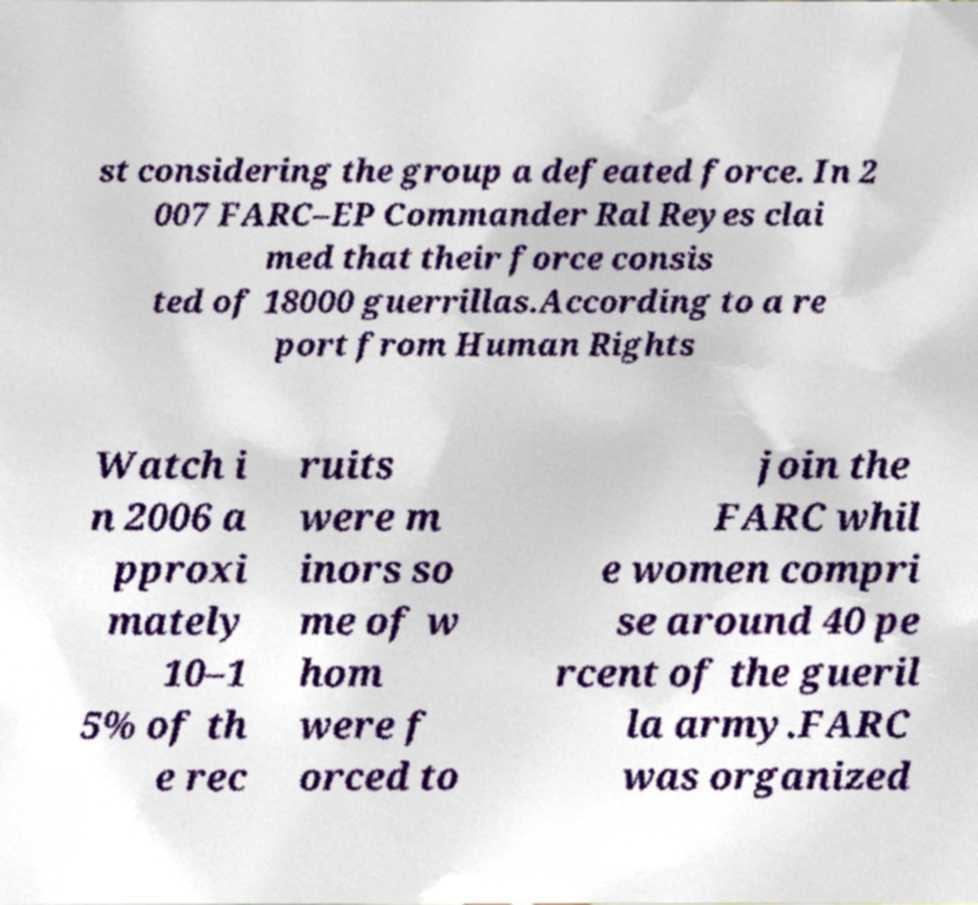I need the written content from this picture converted into text. Can you do that? st considering the group a defeated force. In 2 007 FARC–EP Commander Ral Reyes clai med that their force consis ted of 18000 guerrillas.According to a re port from Human Rights Watch i n 2006 a pproxi mately 10–1 5% of th e rec ruits were m inors so me of w hom were f orced to join the FARC whil e women compri se around 40 pe rcent of the gueril la army.FARC was organized 